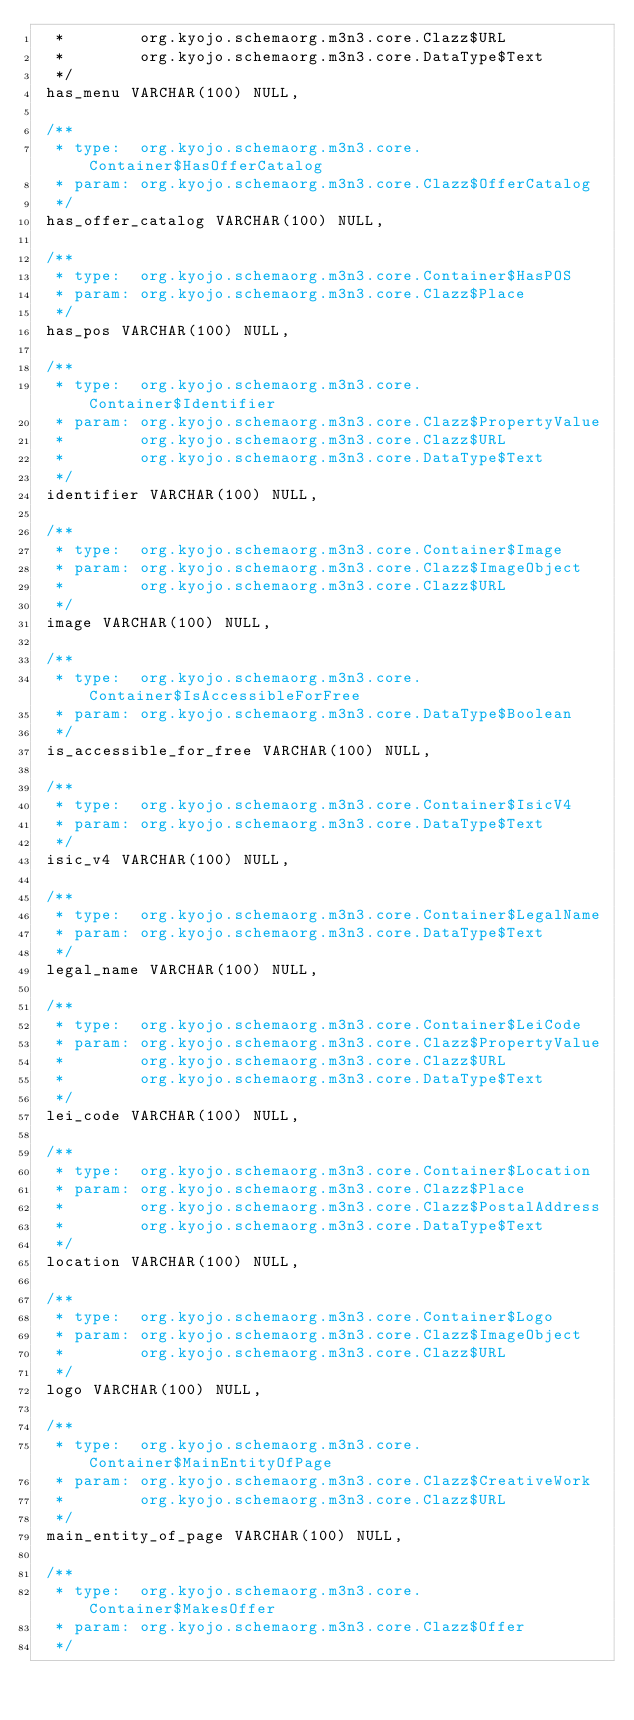Convert code to text. <code><loc_0><loc_0><loc_500><loc_500><_SQL_>  *        org.kyojo.schemaorg.m3n3.core.Clazz$URL
  *        org.kyojo.schemaorg.m3n3.core.DataType$Text
  */
 has_menu VARCHAR(100) NULL,

 /**
  * type:  org.kyojo.schemaorg.m3n3.core.Container$HasOfferCatalog
  * param: org.kyojo.schemaorg.m3n3.core.Clazz$OfferCatalog
  */
 has_offer_catalog VARCHAR(100) NULL,

 /**
  * type:  org.kyojo.schemaorg.m3n3.core.Container$HasPOS
  * param: org.kyojo.schemaorg.m3n3.core.Clazz$Place
  */
 has_pos VARCHAR(100) NULL,

 /**
  * type:  org.kyojo.schemaorg.m3n3.core.Container$Identifier
  * param: org.kyojo.schemaorg.m3n3.core.Clazz$PropertyValue
  *        org.kyojo.schemaorg.m3n3.core.Clazz$URL
  *        org.kyojo.schemaorg.m3n3.core.DataType$Text
  */
 identifier VARCHAR(100) NULL,

 /**
  * type:  org.kyojo.schemaorg.m3n3.core.Container$Image
  * param: org.kyojo.schemaorg.m3n3.core.Clazz$ImageObject
  *        org.kyojo.schemaorg.m3n3.core.Clazz$URL
  */
 image VARCHAR(100) NULL,

 /**
  * type:  org.kyojo.schemaorg.m3n3.core.Container$IsAccessibleForFree
  * param: org.kyojo.schemaorg.m3n3.core.DataType$Boolean
  */
 is_accessible_for_free VARCHAR(100) NULL,

 /**
  * type:  org.kyojo.schemaorg.m3n3.core.Container$IsicV4
  * param: org.kyojo.schemaorg.m3n3.core.DataType$Text
  */
 isic_v4 VARCHAR(100) NULL,

 /**
  * type:  org.kyojo.schemaorg.m3n3.core.Container$LegalName
  * param: org.kyojo.schemaorg.m3n3.core.DataType$Text
  */
 legal_name VARCHAR(100) NULL,

 /**
  * type:  org.kyojo.schemaorg.m3n3.core.Container$LeiCode
  * param: org.kyojo.schemaorg.m3n3.core.Clazz$PropertyValue
  *        org.kyojo.schemaorg.m3n3.core.Clazz$URL
  *        org.kyojo.schemaorg.m3n3.core.DataType$Text
  */
 lei_code VARCHAR(100) NULL,

 /**
  * type:  org.kyojo.schemaorg.m3n3.core.Container$Location
  * param: org.kyojo.schemaorg.m3n3.core.Clazz$Place
  *        org.kyojo.schemaorg.m3n3.core.Clazz$PostalAddress
  *        org.kyojo.schemaorg.m3n3.core.DataType$Text
  */
 location VARCHAR(100) NULL,

 /**
  * type:  org.kyojo.schemaorg.m3n3.core.Container$Logo
  * param: org.kyojo.schemaorg.m3n3.core.Clazz$ImageObject
  *        org.kyojo.schemaorg.m3n3.core.Clazz$URL
  */
 logo VARCHAR(100) NULL,

 /**
  * type:  org.kyojo.schemaorg.m3n3.core.Container$MainEntityOfPage
  * param: org.kyojo.schemaorg.m3n3.core.Clazz$CreativeWork
  *        org.kyojo.schemaorg.m3n3.core.Clazz$URL
  */
 main_entity_of_page VARCHAR(100) NULL,

 /**
  * type:  org.kyojo.schemaorg.m3n3.core.Container$MakesOffer
  * param: org.kyojo.schemaorg.m3n3.core.Clazz$Offer
  */</code> 